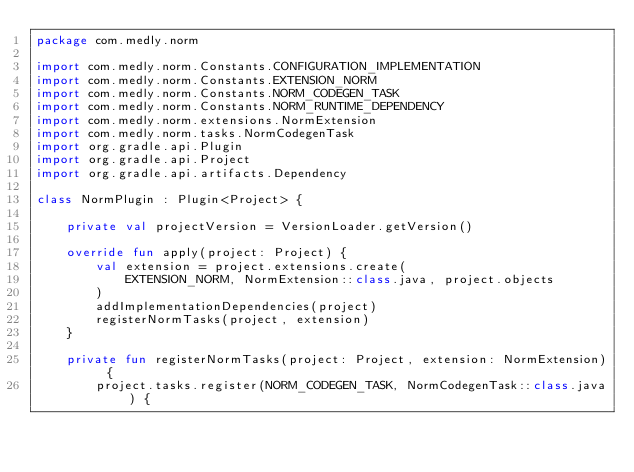<code> <loc_0><loc_0><loc_500><loc_500><_Kotlin_>package com.medly.norm

import com.medly.norm.Constants.CONFIGURATION_IMPLEMENTATION
import com.medly.norm.Constants.EXTENSION_NORM
import com.medly.norm.Constants.NORM_CODEGEN_TASK
import com.medly.norm.Constants.NORM_RUNTIME_DEPENDENCY
import com.medly.norm.extensions.NormExtension
import com.medly.norm.tasks.NormCodegenTask
import org.gradle.api.Plugin
import org.gradle.api.Project
import org.gradle.api.artifacts.Dependency

class NormPlugin : Plugin<Project> {

    private val projectVersion = VersionLoader.getVersion()

    override fun apply(project: Project) {
        val extension = project.extensions.create(
            EXTENSION_NORM, NormExtension::class.java, project.objects
        )
        addImplementationDependencies(project)
        registerNormTasks(project, extension)
    }

    private fun registerNormTasks(project: Project, extension: NormExtension) {
        project.tasks.register(NORM_CODEGEN_TASK, NormCodegenTask::class.java) {</code> 